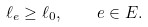<formula> <loc_0><loc_0><loc_500><loc_500>\ell _ { e } \geq \ell _ { 0 } , \quad e \in E .</formula> 